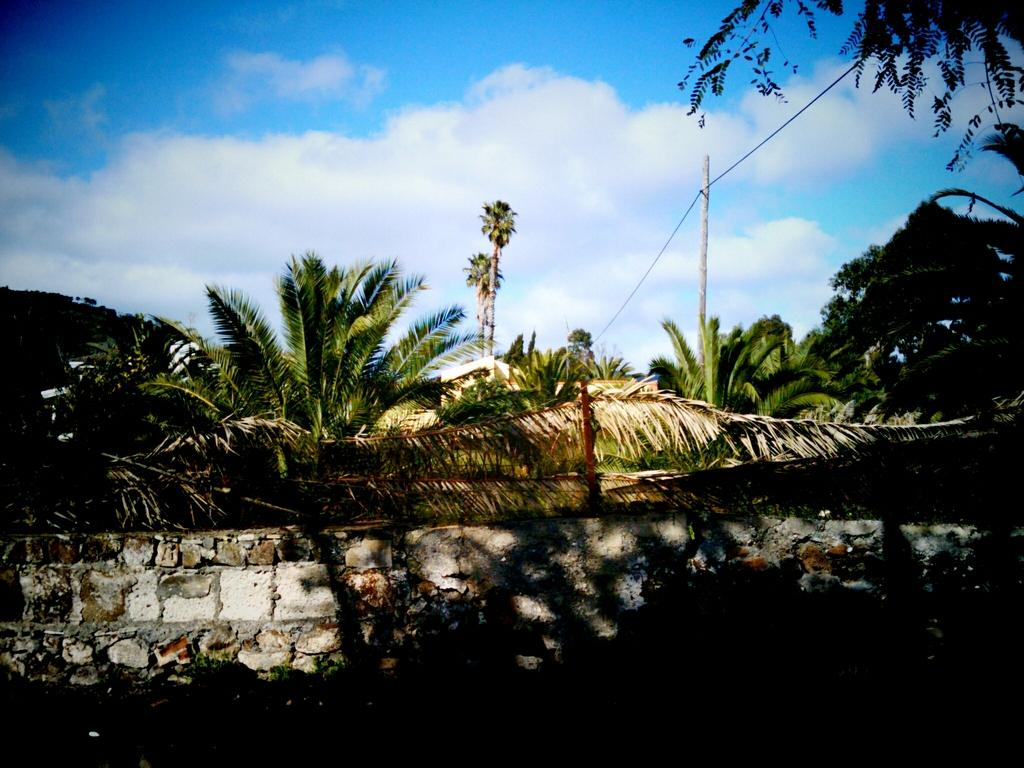What is the main structure visible in the image? There is a wall in the image. What can be seen behind the wall? There is a group of trees behind the wall. What other object is present in the image? There is a pole with a wire in the image. What is visible at the top of the image? The sky is visible at the top of the image. Who is the owner of the milk seen in the image? There is no milk present in the image, so it is not possible to determine the owner. 